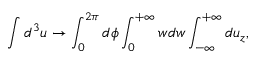Convert formula to latex. <formula><loc_0><loc_0><loc_500><loc_500>\int d ^ { 3 } u \rightarrow \int _ { 0 } ^ { 2 \pi } d \phi \int _ { 0 } ^ { + \infty } w d w \int _ { - \infty } ^ { + \infty } d u _ { z } ,</formula> 